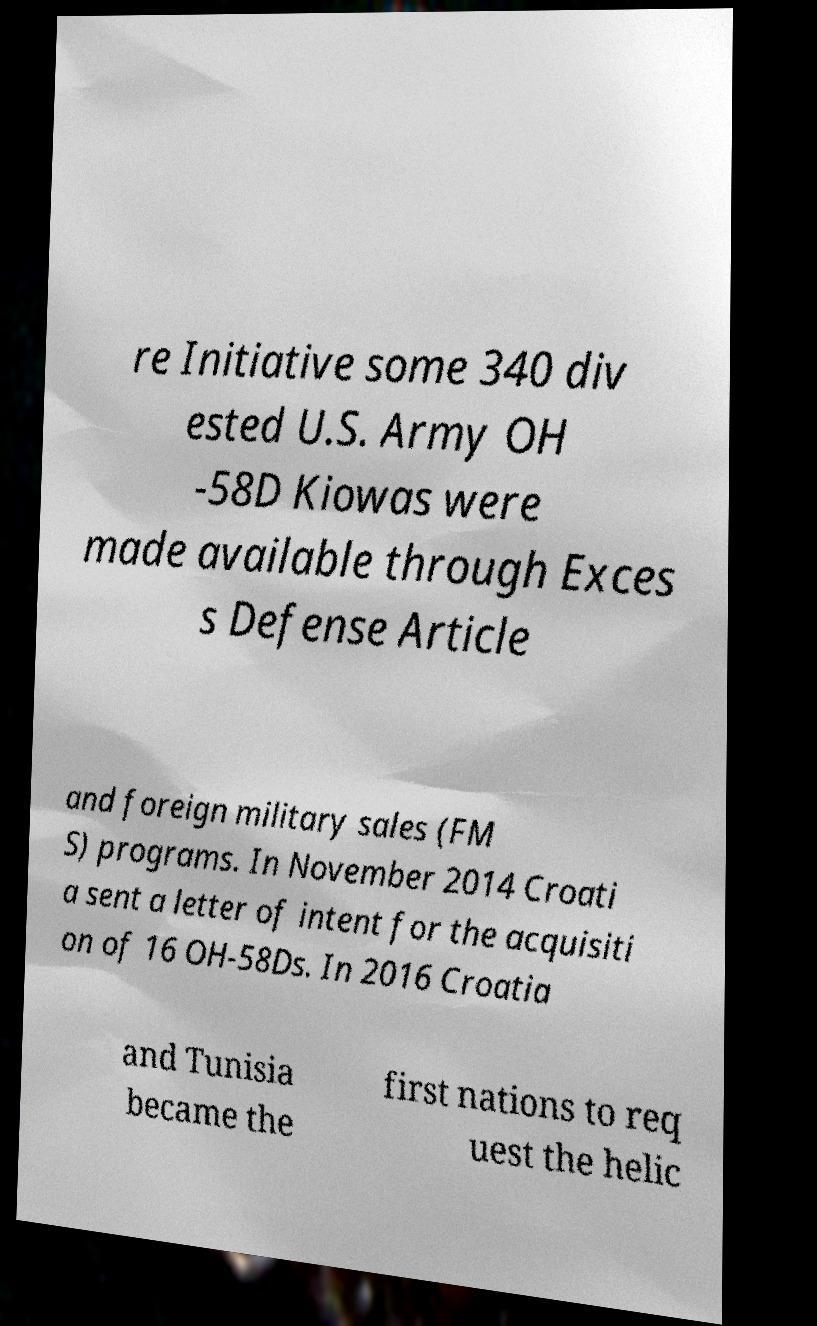Please read and relay the text visible in this image. What does it say? re Initiative some 340 div ested U.S. Army OH -58D Kiowas were made available through Exces s Defense Article and foreign military sales (FM S) programs. In November 2014 Croati a sent a letter of intent for the acquisiti on of 16 OH-58Ds. In 2016 Croatia and Tunisia became the first nations to req uest the helic 